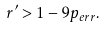<formula> <loc_0><loc_0><loc_500><loc_500>r ^ { \prime } > 1 - 9 p _ { e r r } .</formula> 